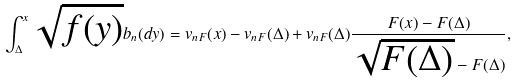Convert formula to latex. <formula><loc_0><loc_0><loc_500><loc_500>\int _ { \Delta } ^ { x } \sqrt { f ( y ) } b _ { n } ( d y ) = v _ { n F } ( x ) - v _ { n F } ( \Delta ) + v _ { n F } ( \Delta ) \frac { F ( x ) - F ( \Delta ) } { \sqrt { F ( \Delta ) } - F ( \Delta ) } ,</formula> 